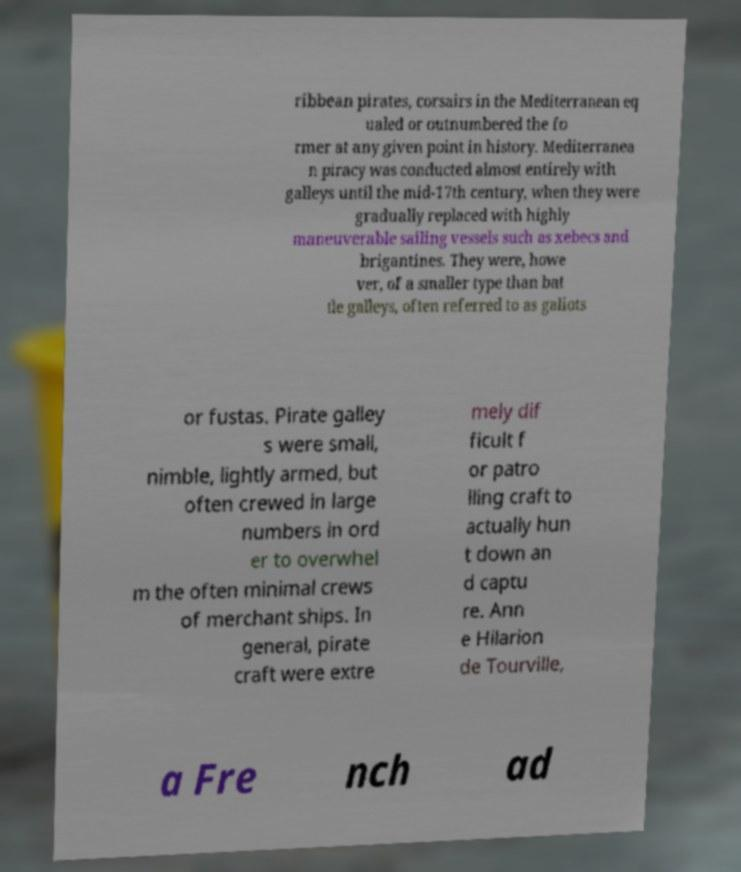Can you accurately transcribe the text from the provided image for me? ribbean pirates, corsairs in the Mediterranean eq ualed or outnumbered the fo rmer at any given point in history. Mediterranea n piracy was conducted almost entirely with galleys until the mid-17th century, when they were gradually replaced with highly maneuverable sailing vessels such as xebecs and brigantines. They were, howe ver, of a smaller type than bat tle galleys, often referred to as galiots or fustas. Pirate galley s were small, nimble, lightly armed, but often crewed in large numbers in ord er to overwhel m the often minimal crews of merchant ships. In general, pirate craft were extre mely dif ficult f or patro lling craft to actually hun t down an d captu re. Ann e Hilarion de Tourville, a Fre nch ad 